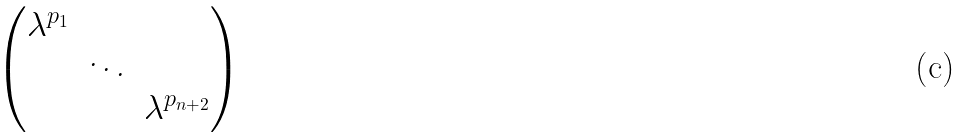Convert formula to latex. <formula><loc_0><loc_0><loc_500><loc_500>\begin{pmatrix} \lambda ^ { p _ { 1 } } \\ & \ddots \\ & & \lambda ^ { p _ { n + 2 } } \end{pmatrix}</formula> 